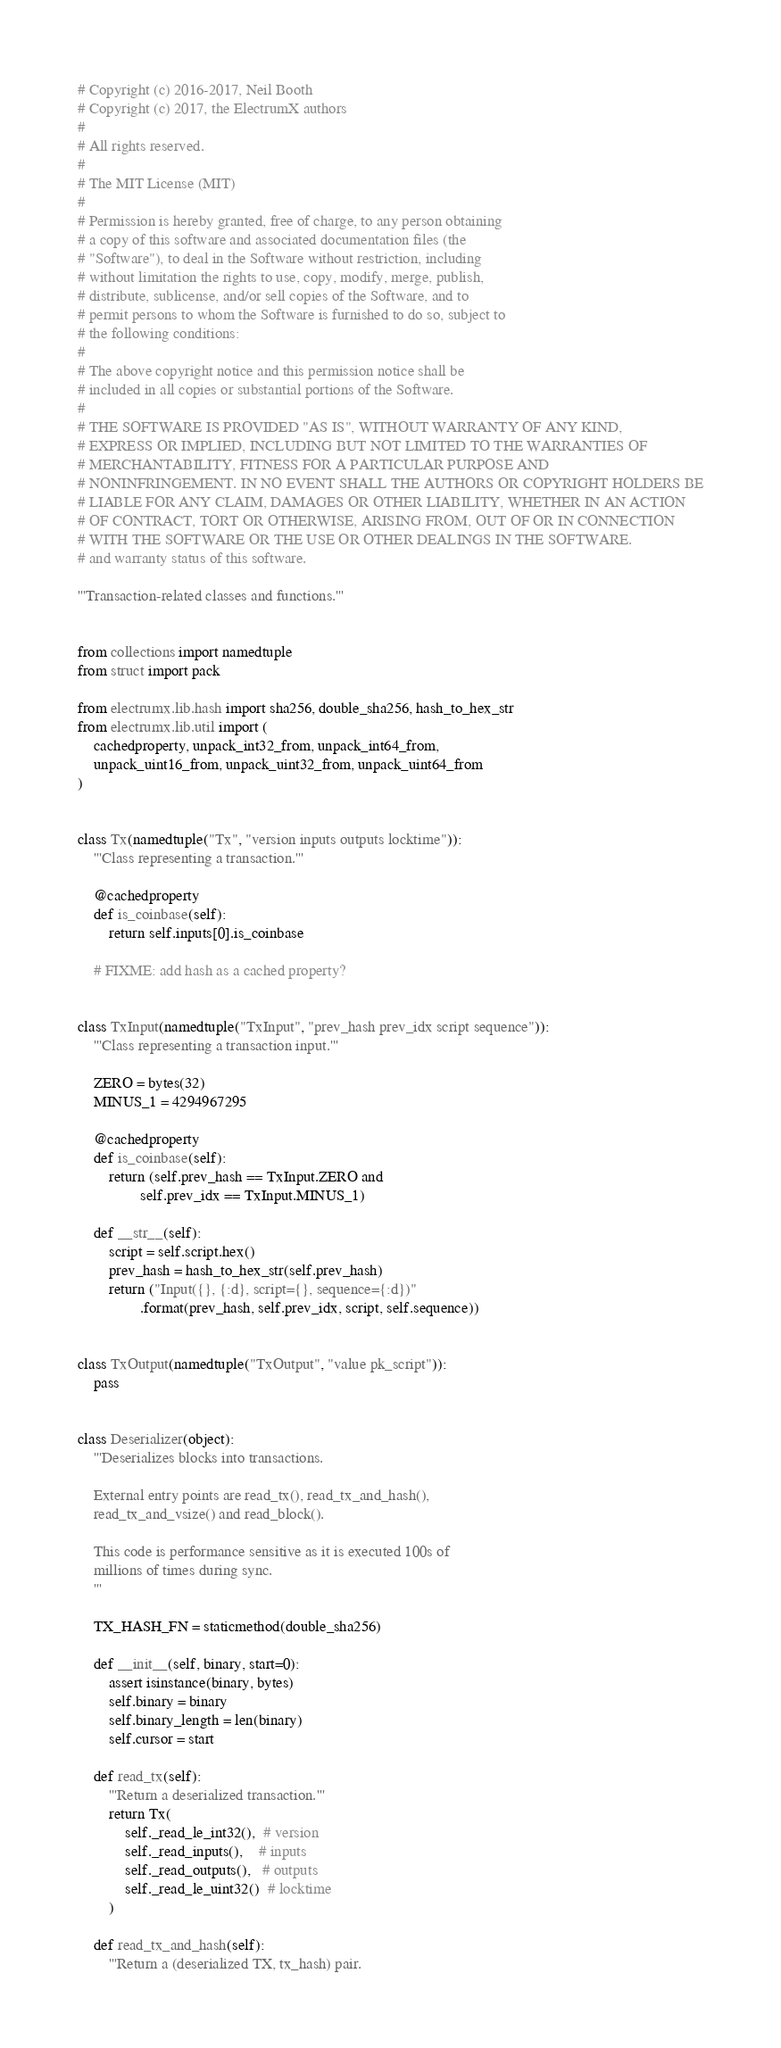<code> <loc_0><loc_0><loc_500><loc_500><_Python_># Copyright (c) 2016-2017, Neil Booth
# Copyright (c) 2017, the ElectrumX authors
#
# All rights reserved.
#
# The MIT License (MIT)
#
# Permission is hereby granted, free of charge, to any person obtaining
# a copy of this software and associated documentation files (the
# "Software"), to deal in the Software without restriction, including
# without limitation the rights to use, copy, modify, merge, publish,
# distribute, sublicense, and/or sell copies of the Software, and to
# permit persons to whom the Software is furnished to do so, subject to
# the following conditions:
#
# The above copyright notice and this permission notice shall be
# included in all copies or substantial portions of the Software.
#
# THE SOFTWARE IS PROVIDED "AS IS", WITHOUT WARRANTY OF ANY KIND,
# EXPRESS OR IMPLIED, INCLUDING BUT NOT LIMITED TO THE WARRANTIES OF
# MERCHANTABILITY, FITNESS FOR A PARTICULAR PURPOSE AND
# NONINFRINGEMENT. IN NO EVENT SHALL THE AUTHORS OR COPYRIGHT HOLDERS BE
# LIABLE FOR ANY CLAIM, DAMAGES OR OTHER LIABILITY, WHETHER IN AN ACTION
# OF CONTRACT, TORT OR OTHERWISE, ARISING FROM, OUT OF OR IN CONNECTION
# WITH THE SOFTWARE OR THE USE OR OTHER DEALINGS IN THE SOFTWARE.
# and warranty status of this software.

'''Transaction-related classes and functions.'''


from collections import namedtuple
from struct import pack

from electrumx.lib.hash import sha256, double_sha256, hash_to_hex_str
from electrumx.lib.util import (
    cachedproperty, unpack_int32_from, unpack_int64_from,
    unpack_uint16_from, unpack_uint32_from, unpack_uint64_from
)


class Tx(namedtuple("Tx", "version inputs outputs locktime")):
    '''Class representing a transaction.'''

    @cachedproperty
    def is_coinbase(self):
        return self.inputs[0].is_coinbase

    # FIXME: add hash as a cached property?


class TxInput(namedtuple("TxInput", "prev_hash prev_idx script sequence")):
    '''Class representing a transaction input.'''

    ZERO = bytes(32)
    MINUS_1 = 4294967295

    @cachedproperty
    def is_coinbase(self):
        return (self.prev_hash == TxInput.ZERO and
                self.prev_idx == TxInput.MINUS_1)

    def __str__(self):
        script = self.script.hex()
        prev_hash = hash_to_hex_str(self.prev_hash)
        return ("Input({}, {:d}, script={}, sequence={:d})"
                .format(prev_hash, self.prev_idx, script, self.sequence))


class TxOutput(namedtuple("TxOutput", "value pk_script")):
    pass


class Deserializer(object):
    '''Deserializes blocks into transactions.

    External entry points are read_tx(), read_tx_and_hash(),
    read_tx_and_vsize() and read_block().

    This code is performance sensitive as it is executed 100s of
    millions of times during sync.
    '''

    TX_HASH_FN = staticmethod(double_sha256)

    def __init__(self, binary, start=0):
        assert isinstance(binary, bytes)
        self.binary = binary
        self.binary_length = len(binary)
        self.cursor = start

    def read_tx(self):
        '''Return a deserialized transaction.'''
        return Tx(
            self._read_le_int32(),  # version
            self._read_inputs(),    # inputs
            self._read_outputs(),   # outputs
            self._read_le_uint32()  # locktime
        )

    def read_tx_and_hash(self):
        '''Return a (deserialized TX, tx_hash) pair.
</code> 